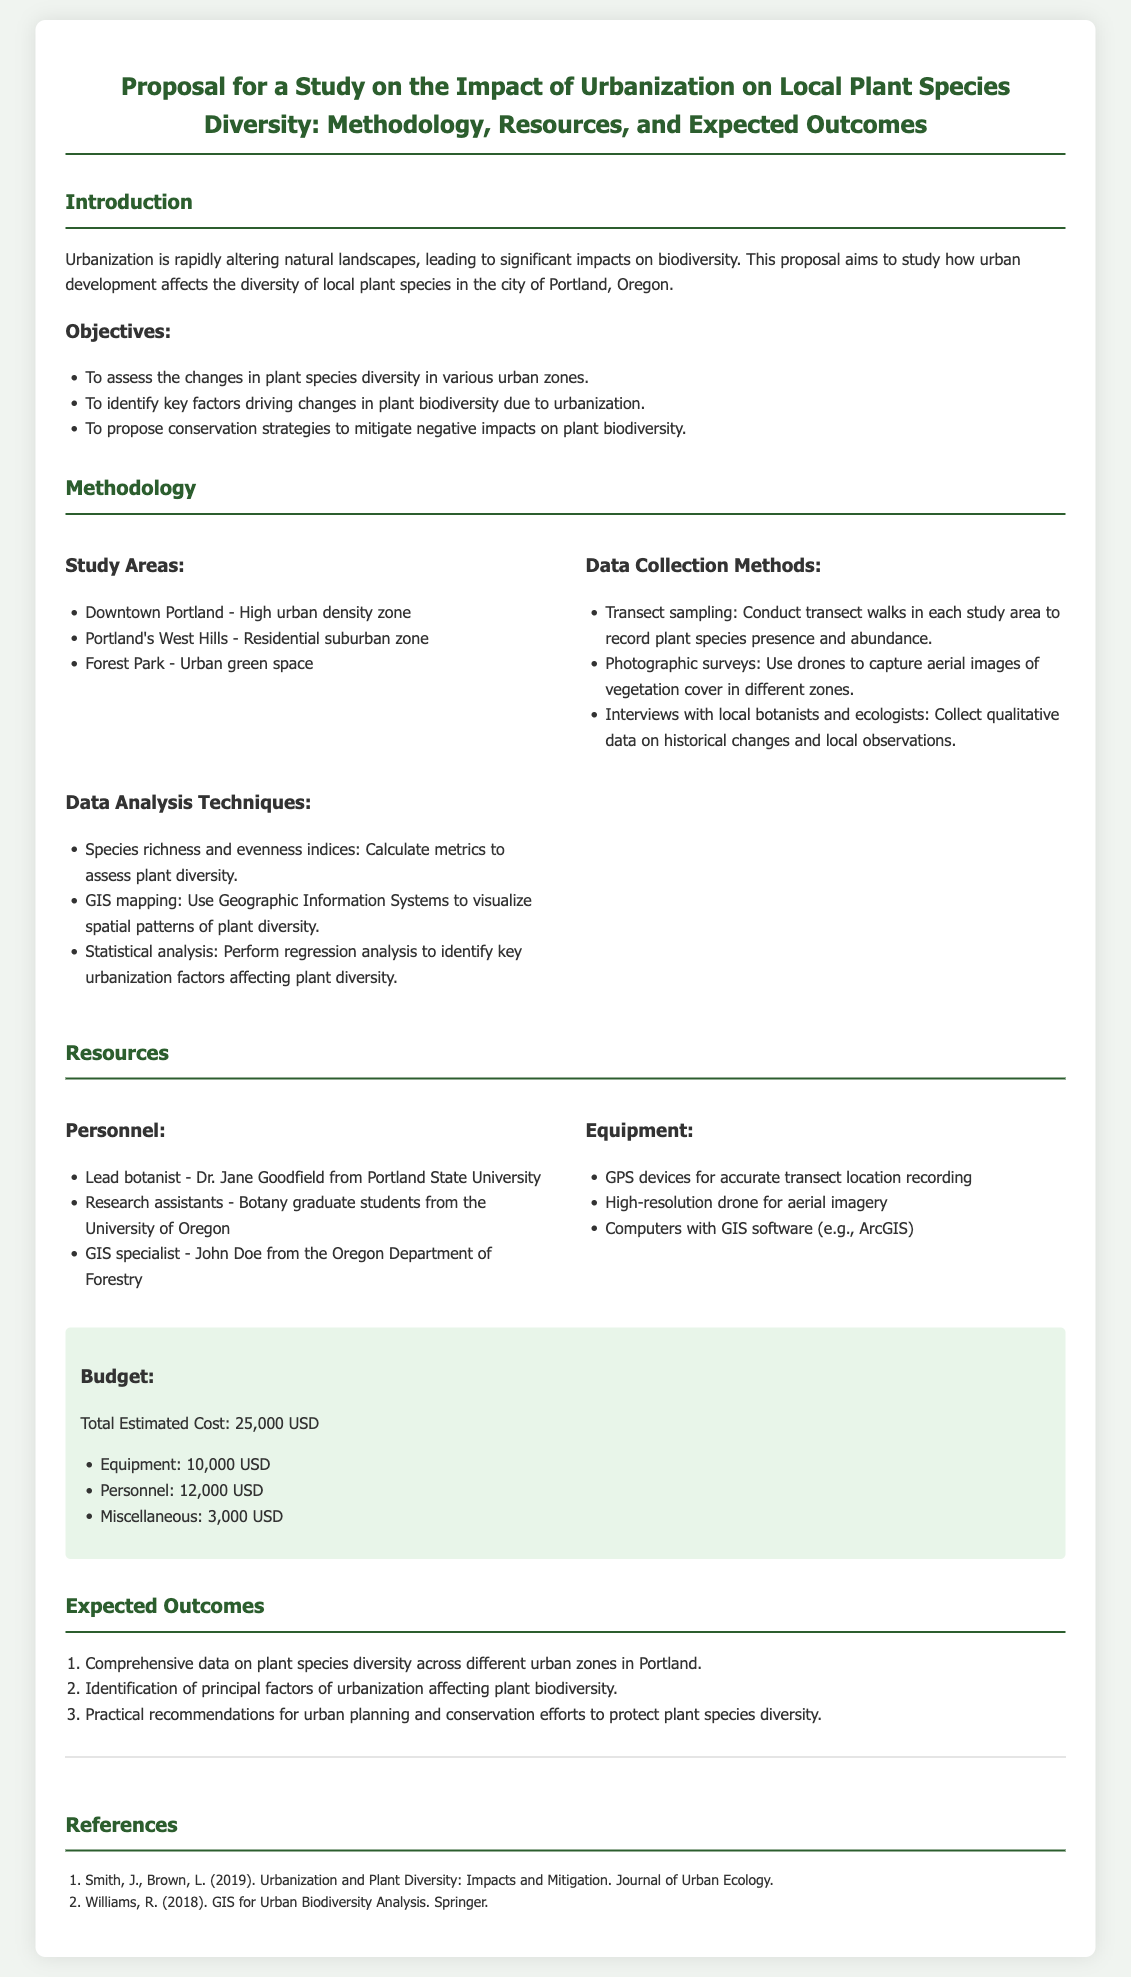What are the study areas? The study areas are specifically listed under the methodology section in the document: Downtown Portland, Portland's West Hills, and Forest Park.
Answer: Downtown Portland, Portland's West Hills, Forest Park Who is the lead botanist for the study? The lead botanist is mentioned in the resources section, specifically under personnel: Dr. Jane Goodfield.
Answer: Dr. Jane Goodfield What data collection method involves drones? The method involving drones is detailed in the data collection methods section, where photographic surveys using drones to capture aerial images of vegetation cover is mentioned.
Answer: Photographic surveys What is the total estimated cost of the project? The total estimated cost is summarized in the budget section, combining all budgetary elements together.
Answer: 25,000 USD How many expected outcomes are listed in the document? The expected outcomes are presented as a numbered list in the expected outcomes section.
Answer: Three What type of species metrics will be calculated? The species metrics to be calculated are mentioned under data analysis techniques, specifically focusing on species richness and evenness indices.
Answer: Species richness and evenness indices Which software is mentioned for GIS analysis? The GIS software for analysis is referenced in the resources section, specifically noting ArcGIS as an example.
Answer: ArcGIS What is the purpose of the proposed study? The purpose of the proposed study is elaborated in the introduction, highlighting the aim to study urbanization’s effects on biodiversity.
Answer: Study how urban development affects the diversity of local plant species 